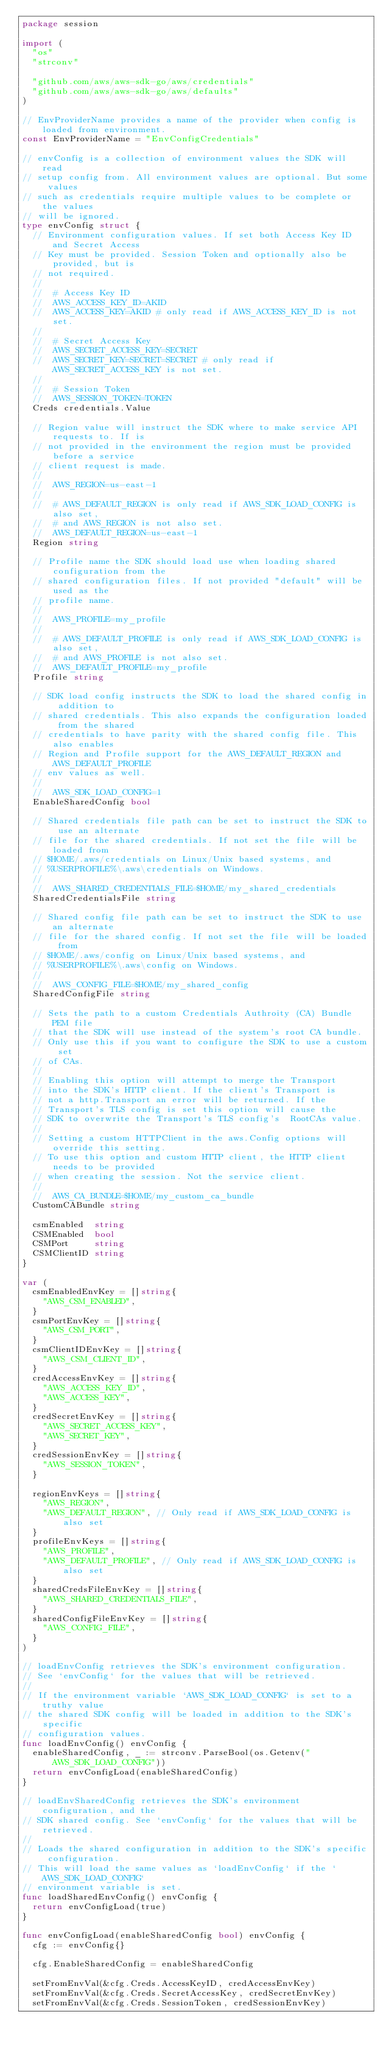<code> <loc_0><loc_0><loc_500><loc_500><_Go_>package session

import (
	"os"
	"strconv"

	"github.com/aws/aws-sdk-go/aws/credentials"
	"github.com/aws/aws-sdk-go/aws/defaults"
)

// EnvProviderName provides a name of the provider when config is loaded from environment.
const EnvProviderName = "EnvConfigCredentials"

// envConfig is a collection of environment values the SDK will read
// setup config from. All environment values are optional. But some values
// such as credentials require multiple values to be complete or the values
// will be ignored.
type envConfig struct {
	// Environment configuration values. If set both Access Key ID and Secret Access
	// Key must be provided. Session Token and optionally also be provided, but is
	// not required.
	//
	//	# Access Key ID
	//	AWS_ACCESS_KEY_ID=AKID
	//	AWS_ACCESS_KEY=AKID # only read if AWS_ACCESS_KEY_ID is not set.
	//
	//	# Secret Access Key
	//	AWS_SECRET_ACCESS_KEY=SECRET
	//	AWS_SECRET_KEY=SECRET=SECRET # only read if AWS_SECRET_ACCESS_KEY is not set.
	//
	//	# Session Token
	//	AWS_SESSION_TOKEN=TOKEN
	Creds credentials.Value

	// Region value will instruct the SDK where to make service API requests to. If is
	// not provided in the environment the region must be provided before a service
	// client request is made.
	//
	//	AWS_REGION=us-east-1
	//
	//	# AWS_DEFAULT_REGION is only read if AWS_SDK_LOAD_CONFIG is also set,
	//	# and AWS_REGION is not also set.
	//	AWS_DEFAULT_REGION=us-east-1
	Region string

	// Profile name the SDK should load use when loading shared configuration from the
	// shared configuration files. If not provided "default" will be used as the
	// profile name.
	//
	//	AWS_PROFILE=my_profile
	//
	//	# AWS_DEFAULT_PROFILE is only read if AWS_SDK_LOAD_CONFIG is also set,
	//	# and AWS_PROFILE is not also set.
	//	AWS_DEFAULT_PROFILE=my_profile
	Profile string

	// SDK load config instructs the SDK to load the shared config in addition to
	// shared credentials. This also expands the configuration loaded from the shared
	// credentials to have parity with the shared config file. This also enables
	// Region and Profile support for the AWS_DEFAULT_REGION and AWS_DEFAULT_PROFILE
	// env values as well.
	//
	//	AWS_SDK_LOAD_CONFIG=1
	EnableSharedConfig bool

	// Shared credentials file path can be set to instruct the SDK to use an alternate
	// file for the shared credentials. If not set the file will be loaded from
	// $HOME/.aws/credentials on Linux/Unix based systems, and
	// %USERPROFILE%\.aws\credentials on Windows.
	//
	//	AWS_SHARED_CREDENTIALS_FILE=$HOME/my_shared_credentials
	SharedCredentialsFile string

	// Shared config file path can be set to instruct the SDK to use an alternate
	// file for the shared config. If not set the file will be loaded from
	// $HOME/.aws/config on Linux/Unix based systems, and
	// %USERPROFILE%\.aws\config on Windows.
	//
	//	AWS_CONFIG_FILE=$HOME/my_shared_config
	SharedConfigFile string

	// Sets the path to a custom Credentials Authroity (CA) Bundle PEM file
	// that the SDK will use instead of the system's root CA bundle.
	// Only use this if you want to configure the SDK to use a custom set
	// of CAs.
	//
	// Enabling this option will attempt to merge the Transport
	// into the SDK's HTTP client. If the client's Transport is
	// not a http.Transport an error will be returned. If the
	// Transport's TLS config is set this option will cause the
	// SDK to overwrite the Transport's TLS config's  RootCAs value.
	//
	// Setting a custom HTTPClient in the aws.Config options will override this setting.
	// To use this option and custom HTTP client, the HTTP client needs to be provided
	// when creating the session. Not the service client.
	//
	//  AWS_CA_BUNDLE=$HOME/my_custom_ca_bundle
	CustomCABundle string

	csmEnabled  string
	CSMEnabled  bool
	CSMPort     string
	CSMClientID string
}

var (
	csmEnabledEnvKey = []string{
		"AWS_CSM_ENABLED",
	}
	csmPortEnvKey = []string{
		"AWS_CSM_PORT",
	}
	csmClientIDEnvKey = []string{
		"AWS_CSM_CLIENT_ID",
	}
	credAccessEnvKey = []string{
		"AWS_ACCESS_KEY_ID",
		"AWS_ACCESS_KEY",
	}
	credSecretEnvKey = []string{
		"AWS_SECRET_ACCESS_KEY",
		"AWS_SECRET_KEY",
	}
	credSessionEnvKey = []string{
		"AWS_SESSION_TOKEN",
	}

	regionEnvKeys = []string{
		"AWS_REGION",
		"AWS_DEFAULT_REGION", // Only read if AWS_SDK_LOAD_CONFIG is also set
	}
	profileEnvKeys = []string{
		"AWS_PROFILE",
		"AWS_DEFAULT_PROFILE", // Only read if AWS_SDK_LOAD_CONFIG is also set
	}
	sharedCredsFileEnvKey = []string{
		"AWS_SHARED_CREDENTIALS_FILE",
	}
	sharedConfigFileEnvKey = []string{
		"AWS_CONFIG_FILE",
	}
)

// loadEnvConfig retrieves the SDK's environment configuration.
// See `envConfig` for the values that will be retrieved.
//
// If the environment variable `AWS_SDK_LOAD_CONFIG` is set to a truthy value
// the shared SDK config will be loaded in addition to the SDK's specific
// configuration values.
func loadEnvConfig() envConfig {
	enableSharedConfig, _ := strconv.ParseBool(os.Getenv("AWS_SDK_LOAD_CONFIG"))
	return envConfigLoad(enableSharedConfig)
}

// loadEnvSharedConfig retrieves the SDK's environment configuration, and the
// SDK shared config. See `envConfig` for the values that will be retrieved.
//
// Loads the shared configuration in addition to the SDK's specific configuration.
// This will load the same values as `loadEnvConfig` if the `AWS_SDK_LOAD_CONFIG`
// environment variable is set.
func loadSharedEnvConfig() envConfig {
	return envConfigLoad(true)
}

func envConfigLoad(enableSharedConfig bool) envConfig {
	cfg := envConfig{}

	cfg.EnableSharedConfig = enableSharedConfig

	setFromEnvVal(&cfg.Creds.AccessKeyID, credAccessEnvKey)
	setFromEnvVal(&cfg.Creds.SecretAccessKey, credSecretEnvKey)
	setFromEnvVal(&cfg.Creds.SessionToken, credSessionEnvKey)</code> 